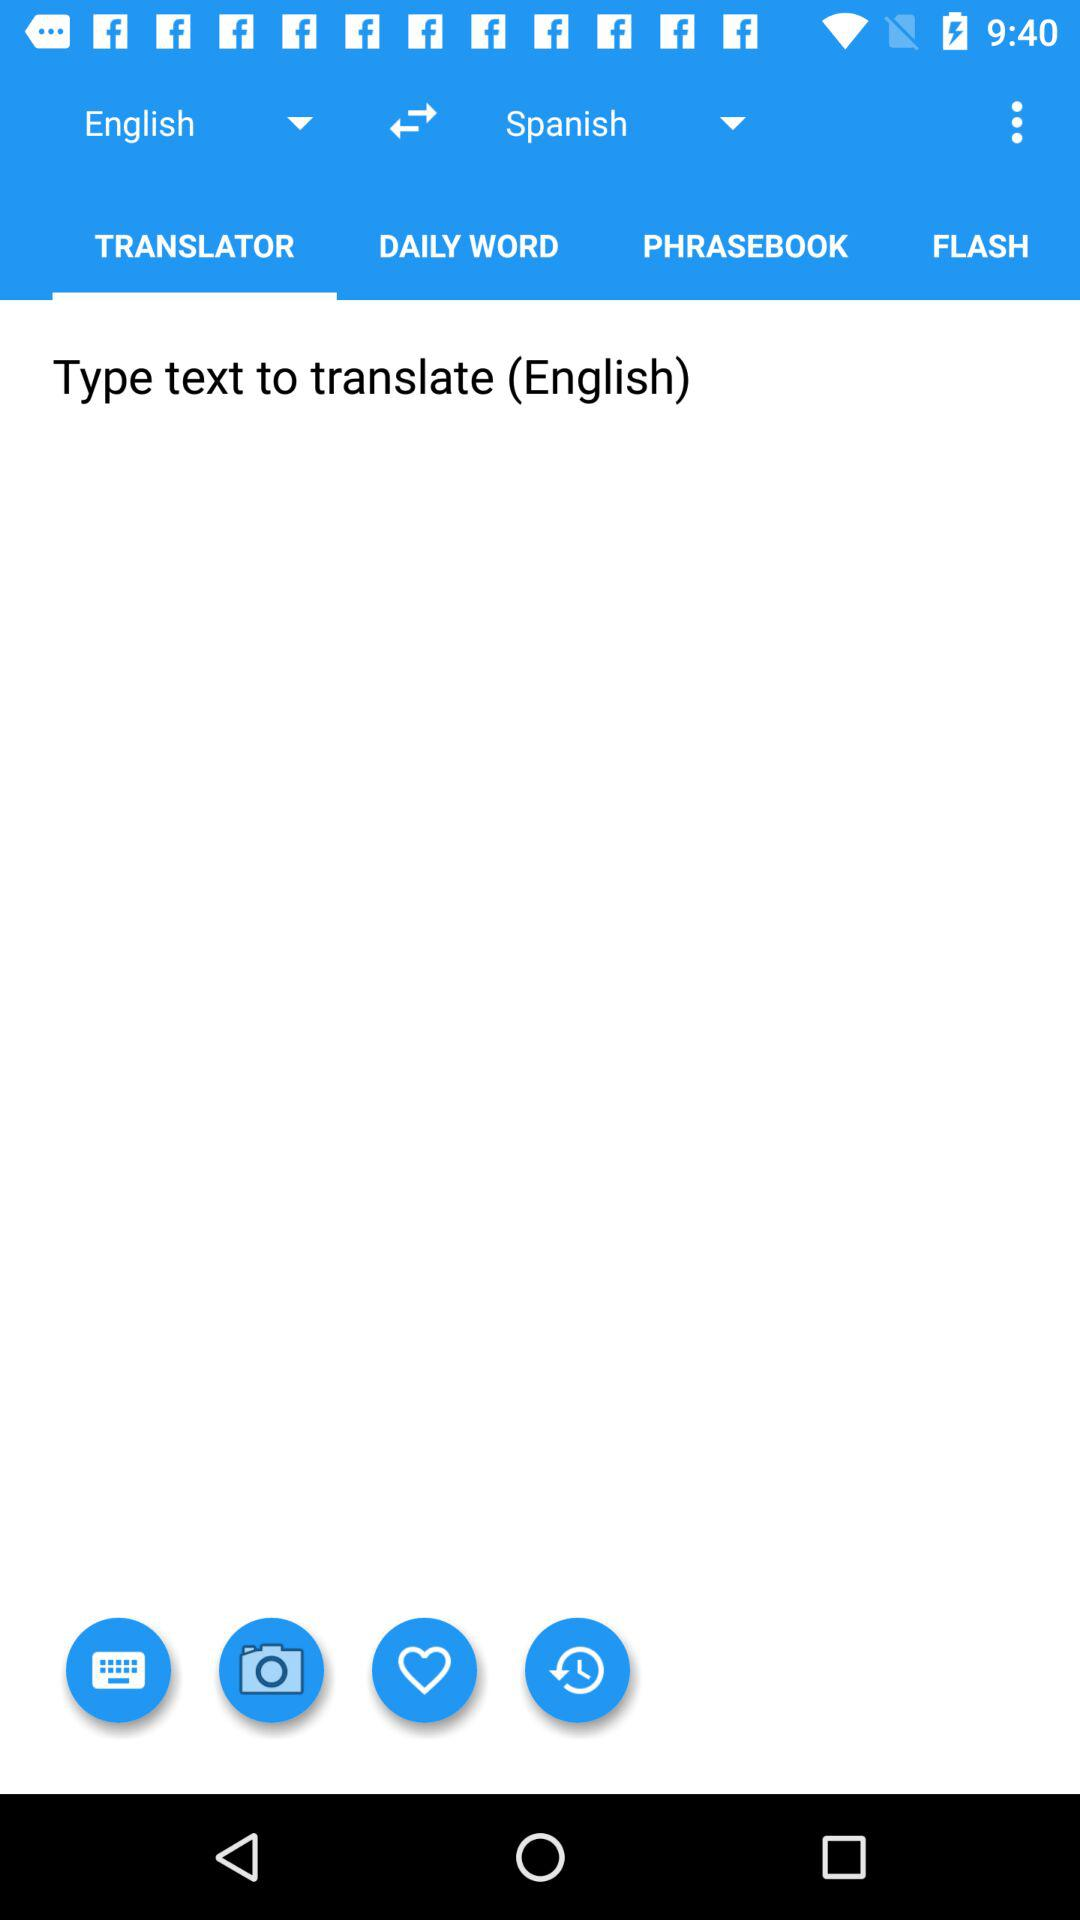Which tab is selected? The selected tab is "TRANSLATOR". 